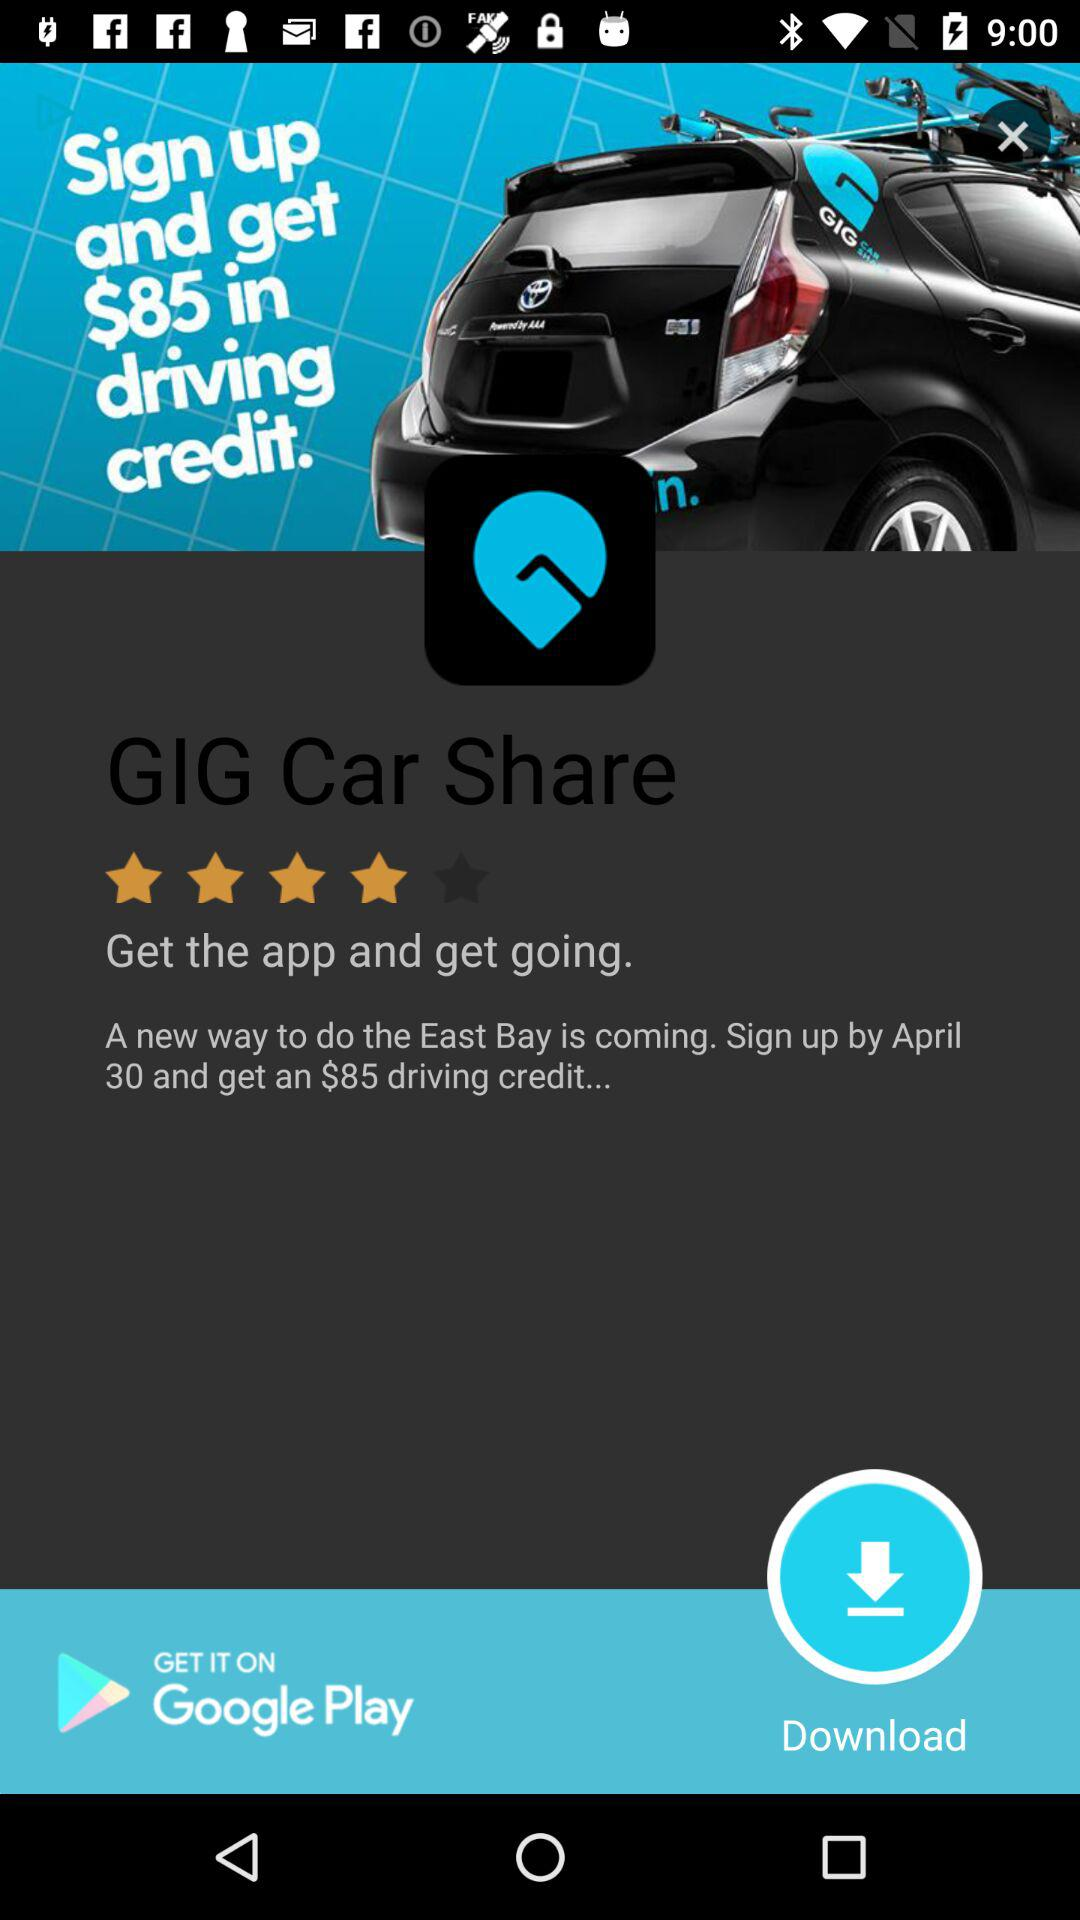How many dollars is the driving credit?
Answer the question using a single word or phrase. $85 